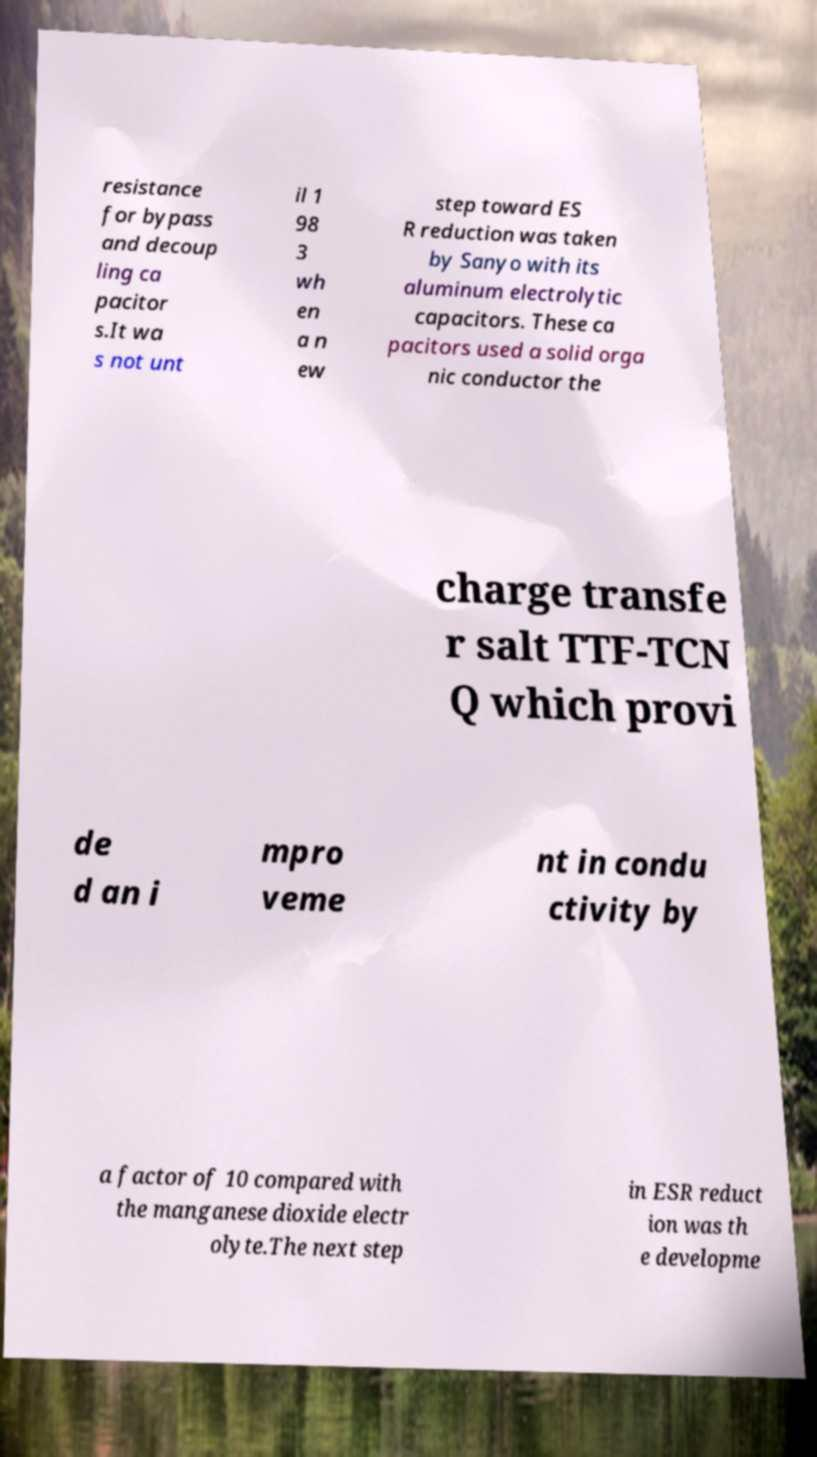Can you accurately transcribe the text from the provided image for me? resistance for bypass and decoup ling ca pacitor s.It wa s not unt il 1 98 3 wh en a n ew step toward ES R reduction was taken by Sanyo with its aluminum electrolytic capacitors. These ca pacitors used a solid orga nic conductor the charge transfe r salt TTF-TCN Q which provi de d an i mpro veme nt in condu ctivity by a factor of 10 compared with the manganese dioxide electr olyte.The next step in ESR reduct ion was th e developme 